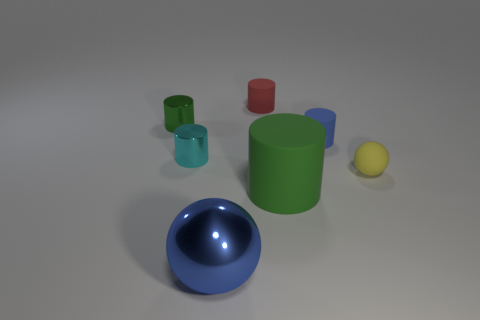What color is the tiny matte ball?
Your response must be concise. Yellow. There is a tiny cylinder that is behind the green shiny cylinder; what number of cylinders are to the right of it?
Your answer should be compact. 2. Are there any large blue shiny spheres behind the large thing that is on the left side of the red cylinder?
Your response must be concise. No. Are there any blue objects behind the tiny ball?
Make the answer very short. Yes. There is a green thing that is on the right side of the large blue ball; does it have the same shape as the red thing?
Make the answer very short. Yes. What number of blue things are the same shape as the tiny yellow object?
Your answer should be compact. 1. Are there any small blue objects made of the same material as the tiny green thing?
Offer a terse response. No. The sphere behind the sphere in front of the big matte thing is made of what material?
Your answer should be very brief. Rubber. What size is the rubber ball that is on the right side of the cyan shiny cylinder?
Give a very brief answer. Small. There is a matte sphere; is its color the same as the tiny matte cylinder to the right of the small red rubber cylinder?
Provide a short and direct response. No. 